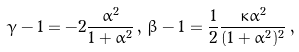Convert formula to latex. <formula><loc_0><loc_0><loc_500><loc_500>\gamma - 1 = - 2 \frac { \alpha ^ { 2 } } { 1 + \alpha ^ { 2 } } \, , \, \beta - 1 = \frac { 1 } { 2 } \frac { \kappa \alpha ^ { 2 } } { ( 1 + \alpha ^ { 2 } ) ^ { 2 } } \, ,</formula> 